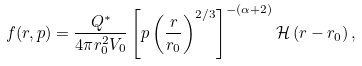Convert formula to latex. <formula><loc_0><loc_0><loc_500><loc_500>f ( r , p ) = \frac { Q ^ { * } } { 4 \pi r _ { 0 } ^ { 2 } V _ { 0 } } \left [ p \left ( \frac { r } { r _ { 0 } } \right ) ^ { 2 / 3 } \right ] ^ { - ( \alpha + 2 ) } \mathcal { H } \left ( r - r _ { 0 } \right ) ,</formula> 